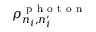Convert formula to latex. <formula><loc_0><loc_0><loc_500><loc_500>\rho _ { n _ { i } , n _ { i } ^ { \prime } } ^ { p h o t o n }</formula> 